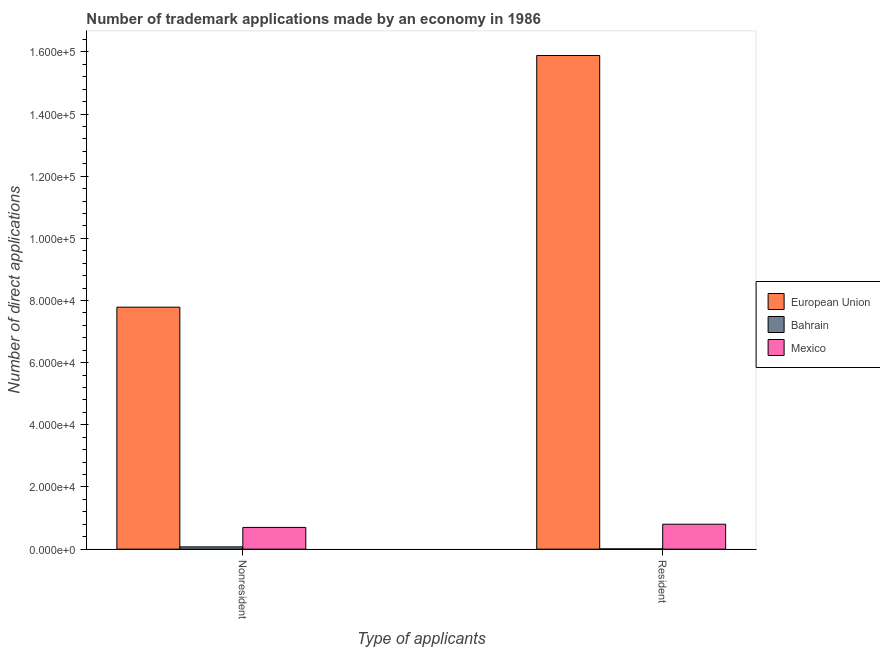How many bars are there on the 1st tick from the left?
Make the answer very short. 3. How many bars are there on the 2nd tick from the right?
Ensure brevity in your answer.  3. What is the label of the 2nd group of bars from the left?
Your answer should be very brief. Resident. What is the number of trademark applications made by non residents in European Union?
Offer a terse response. 7.79e+04. Across all countries, what is the maximum number of trademark applications made by residents?
Your response must be concise. 1.59e+05. Across all countries, what is the minimum number of trademark applications made by residents?
Offer a very short reply. 74. In which country was the number of trademark applications made by residents maximum?
Ensure brevity in your answer.  European Union. In which country was the number of trademark applications made by residents minimum?
Offer a terse response. Bahrain. What is the total number of trademark applications made by non residents in the graph?
Your answer should be very brief. 8.56e+04. What is the difference between the number of trademark applications made by residents in Bahrain and that in Mexico?
Your answer should be compact. -7948. What is the difference between the number of trademark applications made by non residents in Bahrain and the number of trademark applications made by residents in Mexico?
Make the answer very short. -7287. What is the average number of trademark applications made by residents per country?
Offer a very short reply. 5.56e+04. What is the difference between the number of trademark applications made by non residents and number of trademark applications made by residents in Mexico?
Give a very brief answer. -1031. What is the ratio of the number of trademark applications made by residents in European Union to that in Mexico?
Your answer should be compact. 19.8. What does the 2nd bar from the left in Nonresident represents?
Make the answer very short. Bahrain. What does the 1st bar from the right in Nonresident represents?
Offer a terse response. Mexico. How many bars are there?
Provide a short and direct response. 6. How many countries are there in the graph?
Provide a short and direct response. 3. What is the difference between two consecutive major ticks on the Y-axis?
Make the answer very short. 2.00e+04. Are the values on the major ticks of Y-axis written in scientific E-notation?
Ensure brevity in your answer.  Yes. Does the graph contain any zero values?
Offer a very short reply. No. Does the graph contain grids?
Your answer should be very brief. No. Where does the legend appear in the graph?
Provide a succinct answer. Center right. How many legend labels are there?
Make the answer very short. 3. What is the title of the graph?
Offer a very short reply. Number of trademark applications made by an economy in 1986. What is the label or title of the X-axis?
Give a very brief answer. Type of applicants. What is the label or title of the Y-axis?
Offer a very short reply. Number of direct applications. What is the Number of direct applications in European Union in Nonresident?
Provide a short and direct response. 7.79e+04. What is the Number of direct applications in Bahrain in Nonresident?
Make the answer very short. 735. What is the Number of direct applications of Mexico in Nonresident?
Keep it short and to the point. 6991. What is the Number of direct applications of European Union in Resident?
Provide a succinct answer. 1.59e+05. What is the Number of direct applications in Mexico in Resident?
Your response must be concise. 8022. Across all Type of applicants, what is the maximum Number of direct applications in European Union?
Provide a succinct answer. 1.59e+05. Across all Type of applicants, what is the maximum Number of direct applications in Bahrain?
Provide a succinct answer. 735. Across all Type of applicants, what is the maximum Number of direct applications in Mexico?
Your answer should be very brief. 8022. Across all Type of applicants, what is the minimum Number of direct applications of European Union?
Ensure brevity in your answer.  7.79e+04. Across all Type of applicants, what is the minimum Number of direct applications of Mexico?
Make the answer very short. 6991. What is the total Number of direct applications of European Union in the graph?
Give a very brief answer. 2.37e+05. What is the total Number of direct applications in Bahrain in the graph?
Ensure brevity in your answer.  809. What is the total Number of direct applications in Mexico in the graph?
Ensure brevity in your answer.  1.50e+04. What is the difference between the Number of direct applications in European Union in Nonresident and that in Resident?
Ensure brevity in your answer.  -8.10e+04. What is the difference between the Number of direct applications in Bahrain in Nonresident and that in Resident?
Offer a very short reply. 661. What is the difference between the Number of direct applications of Mexico in Nonresident and that in Resident?
Provide a succinct answer. -1031. What is the difference between the Number of direct applications of European Union in Nonresident and the Number of direct applications of Bahrain in Resident?
Offer a very short reply. 7.78e+04. What is the difference between the Number of direct applications of European Union in Nonresident and the Number of direct applications of Mexico in Resident?
Your answer should be very brief. 6.98e+04. What is the difference between the Number of direct applications of Bahrain in Nonresident and the Number of direct applications of Mexico in Resident?
Your response must be concise. -7287. What is the average Number of direct applications in European Union per Type of applicants?
Your answer should be compact. 1.18e+05. What is the average Number of direct applications of Bahrain per Type of applicants?
Give a very brief answer. 404.5. What is the average Number of direct applications of Mexico per Type of applicants?
Offer a very short reply. 7506.5. What is the difference between the Number of direct applications of European Union and Number of direct applications of Bahrain in Nonresident?
Your response must be concise. 7.71e+04. What is the difference between the Number of direct applications in European Union and Number of direct applications in Mexico in Nonresident?
Offer a terse response. 7.09e+04. What is the difference between the Number of direct applications of Bahrain and Number of direct applications of Mexico in Nonresident?
Make the answer very short. -6256. What is the difference between the Number of direct applications of European Union and Number of direct applications of Bahrain in Resident?
Provide a succinct answer. 1.59e+05. What is the difference between the Number of direct applications of European Union and Number of direct applications of Mexico in Resident?
Offer a very short reply. 1.51e+05. What is the difference between the Number of direct applications of Bahrain and Number of direct applications of Mexico in Resident?
Your answer should be compact. -7948. What is the ratio of the Number of direct applications in European Union in Nonresident to that in Resident?
Your answer should be very brief. 0.49. What is the ratio of the Number of direct applications of Bahrain in Nonresident to that in Resident?
Provide a short and direct response. 9.93. What is the ratio of the Number of direct applications of Mexico in Nonresident to that in Resident?
Provide a succinct answer. 0.87. What is the difference between the highest and the second highest Number of direct applications of European Union?
Keep it short and to the point. 8.10e+04. What is the difference between the highest and the second highest Number of direct applications of Bahrain?
Your answer should be compact. 661. What is the difference between the highest and the second highest Number of direct applications in Mexico?
Provide a short and direct response. 1031. What is the difference between the highest and the lowest Number of direct applications of European Union?
Provide a short and direct response. 8.10e+04. What is the difference between the highest and the lowest Number of direct applications of Bahrain?
Offer a terse response. 661. What is the difference between the highest and the lowest Number of direct applications in Mexico?
Provide a short and direct response. 1031. 